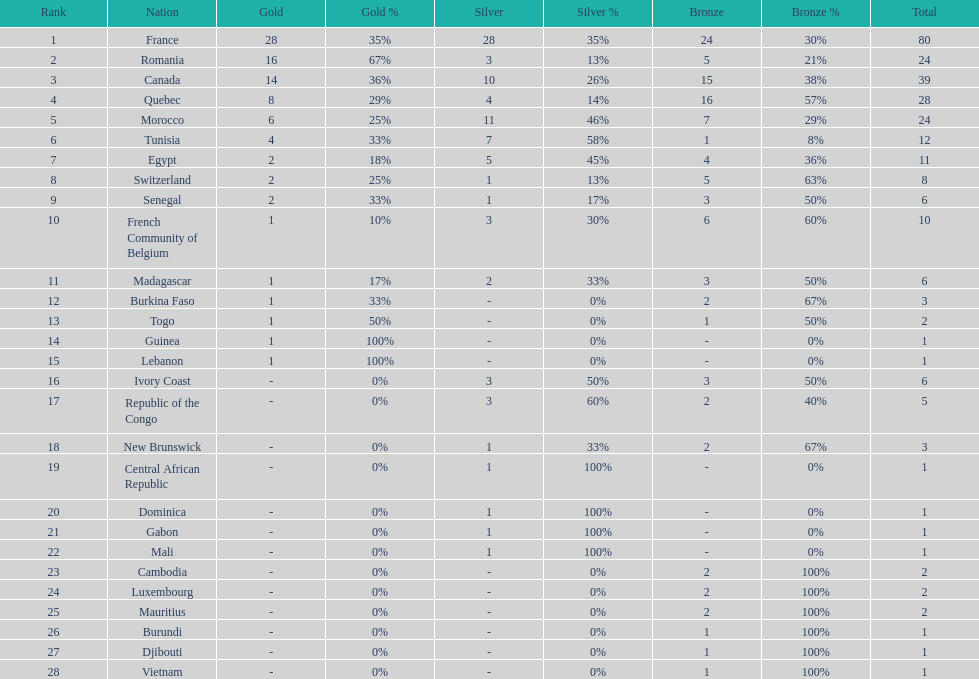Who placed in first according to medals? France. 